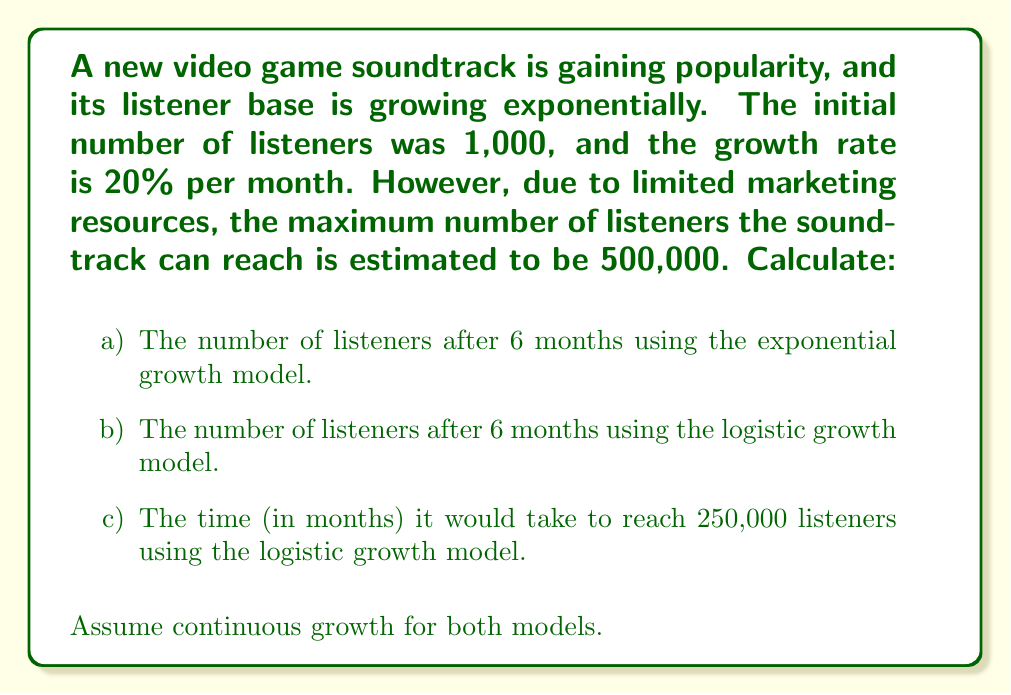Provide a solution to this math problem. Let's approach this problem step by step:

a) Exponential growth model:

The exponential growth model is given by:
$$N(t) = N_0e^{rt}$$
Where:
$N(t)$ is the population at time $t$
$N_0$ is the initial population
$r$ is the growth rate
$t$ is the time

Given:
$N_0 = 1,000$
$r = 0.20$ per month
$t = 6$ months

Plugging these values into the equation:
$$N(6) = 1,000e^{0.20 \times 6} = 1,000e^{1.2} \approx 3,320.12$$

b) Logistic growth model:

The logistic growth model is given by:
$$N(t) = \frac{K}{1 + (\frac{K}{N_0} - 1)e^{-rt}}$$
Where:
$K$ is the carrying capacity

Given:
$K = 500,000$
$N_0 = 1,000$
$r = 0.20$ per month
$t = 6$ months

Plugging these values into the equation:
$$N(6) = \frac{500,000}{1 + (\frac{500,000}{1,000} - 1)e^{-0.20 \times 6}} \approx 3,297.21$$

c) Time to reach 250,000 listeners using the logistic model:

We need to solve the equation:
$$250,000 = \frac{500,000}{1 + (\frac{500,000}{1,000} - 1)e^{-0.20t}}$$

Simplifying:
$$0.5 = \frac{1}{1 + 499e^{-0.20t}}$$
$$2 = 1 + 499e^{-0.20t}$$
$$1 = 499e^{-0.20t}$$
$$\ln(1/499) = -0.20t$$
$$t = -\frac{\ln(1/499)}{0.20} \approx 31.01$$
Answer: a) 3,320 listeners (rounded to nearest whole number)
b) 3,297 listeners (rounded to nearest whole number)
c) 31.01 months 